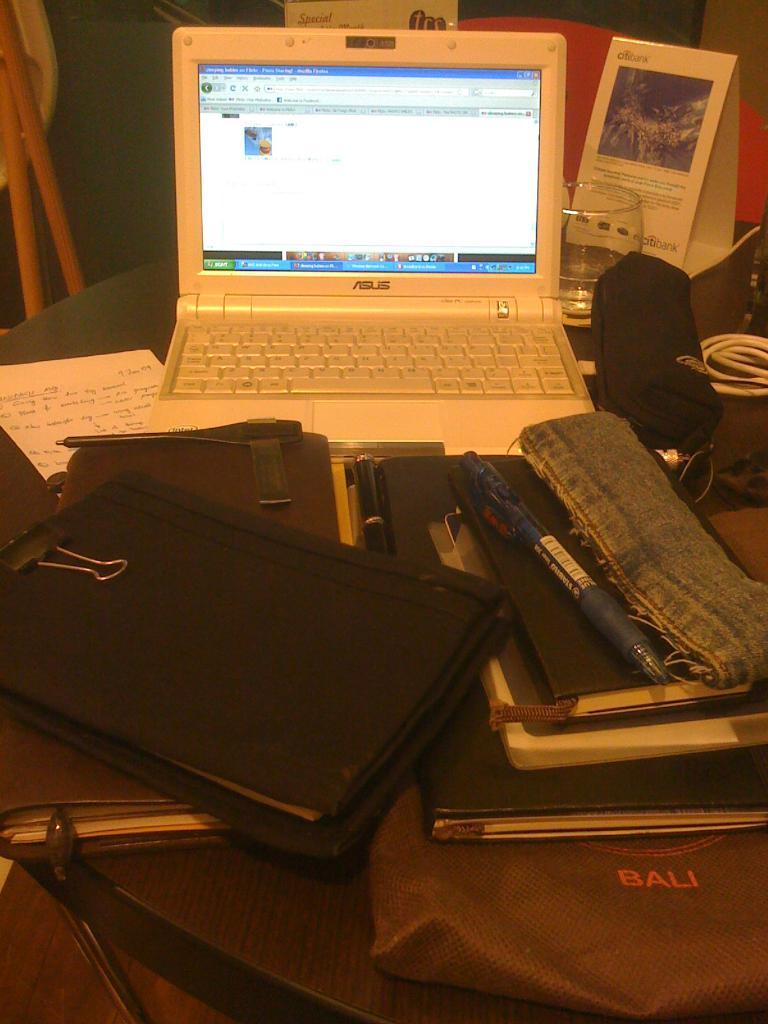Provide a one-sentence caption for the provided image. Asus is the brand shown on this open laptop. 